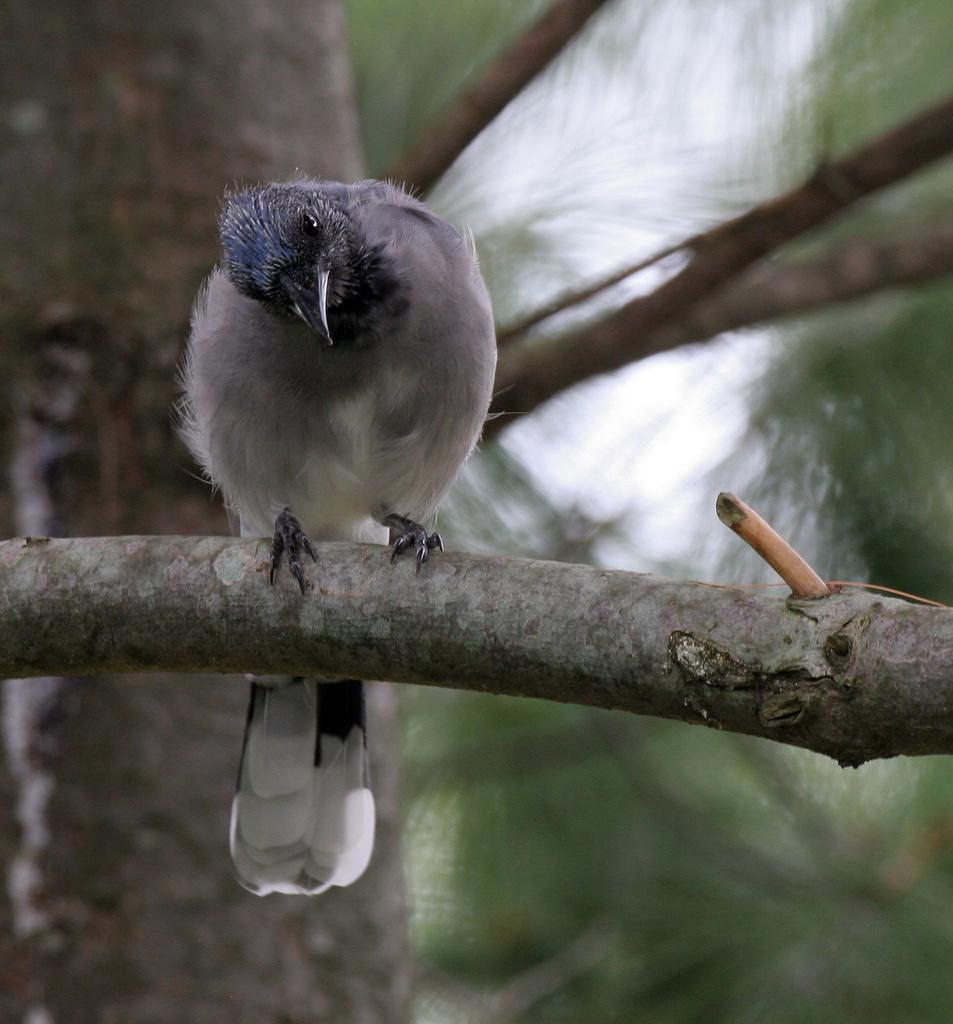What type of animal can be seen in the image? There is a bird in the image. Where is the bird located? The bird is on a branch. Can you describe the background of the image? The background of the image is blurred. What type of wrench is the bird using to fix the van in the image? There is no wrench or van present in the image; it features a bird on a branch with a blurred background. 